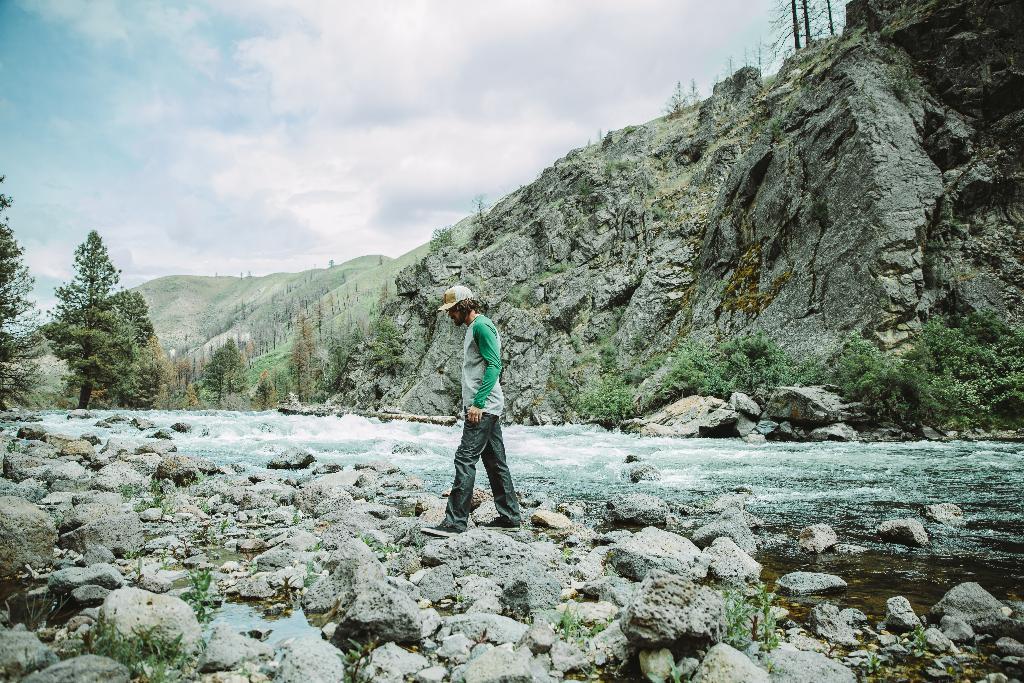Describe this image in one or two sentences. Here we can see a man walking on the stones which are on the ground. In the background we can see water,trees,mountains,rocks and clouds in the sky. 